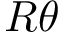<formula> <loc_0><loc_0><loc_500><loc_500>R \theta</formula> 